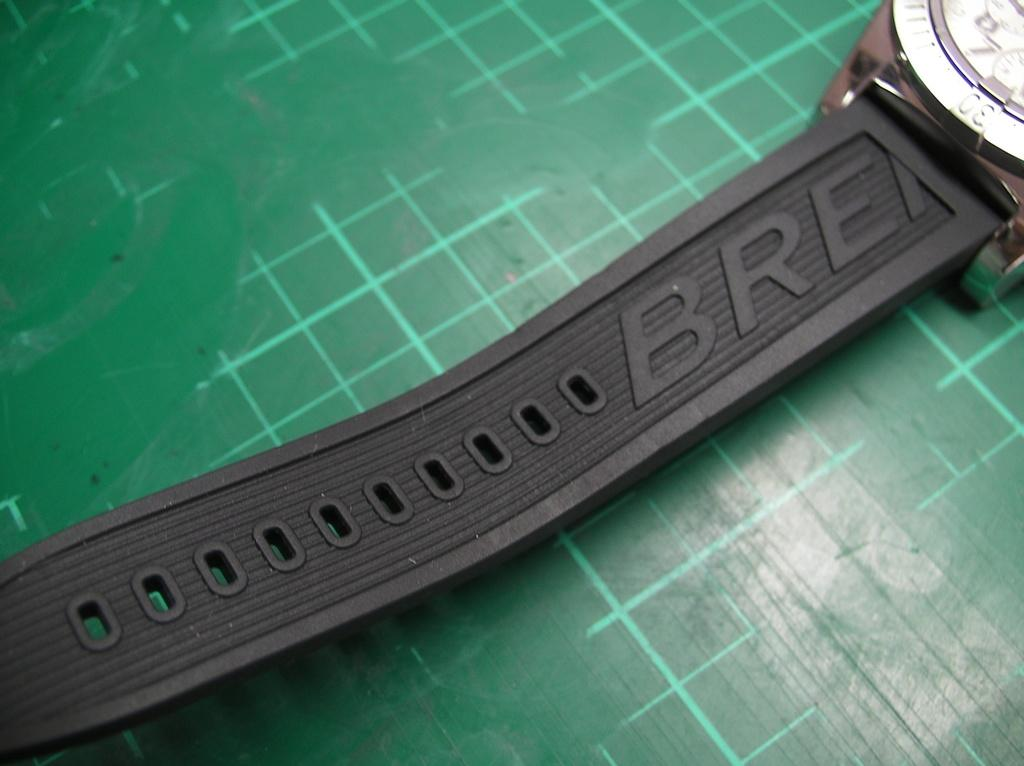<image>
Provide a brief description of the given image. A fit bit device laying on a green and white checked background with letters BRE showing on the band. 